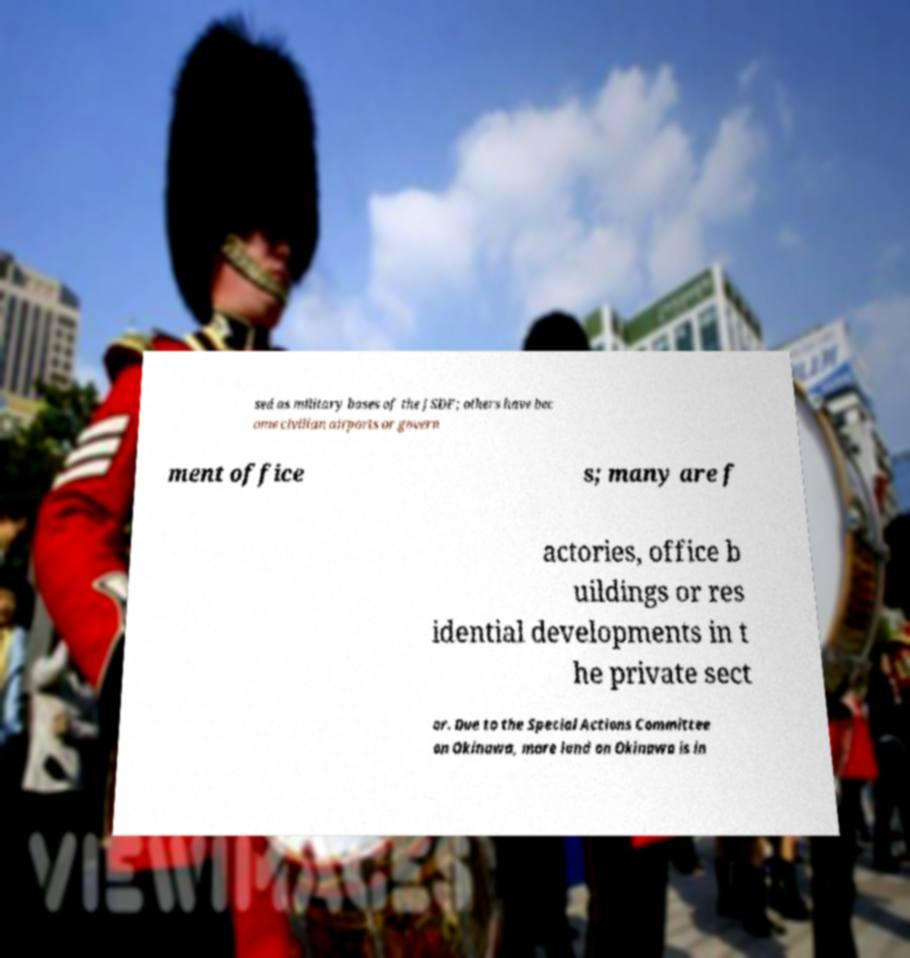I need the written content from this picture converted into text. Can you do that? sed as military bases of the JSDF; others have bec ome civilian airports or govern ment office s; many are f actories, office b uildings or res idential developments in t he private sect or. Due to the Special Actions Committee on Okinawa, more land on Okinawa is in 